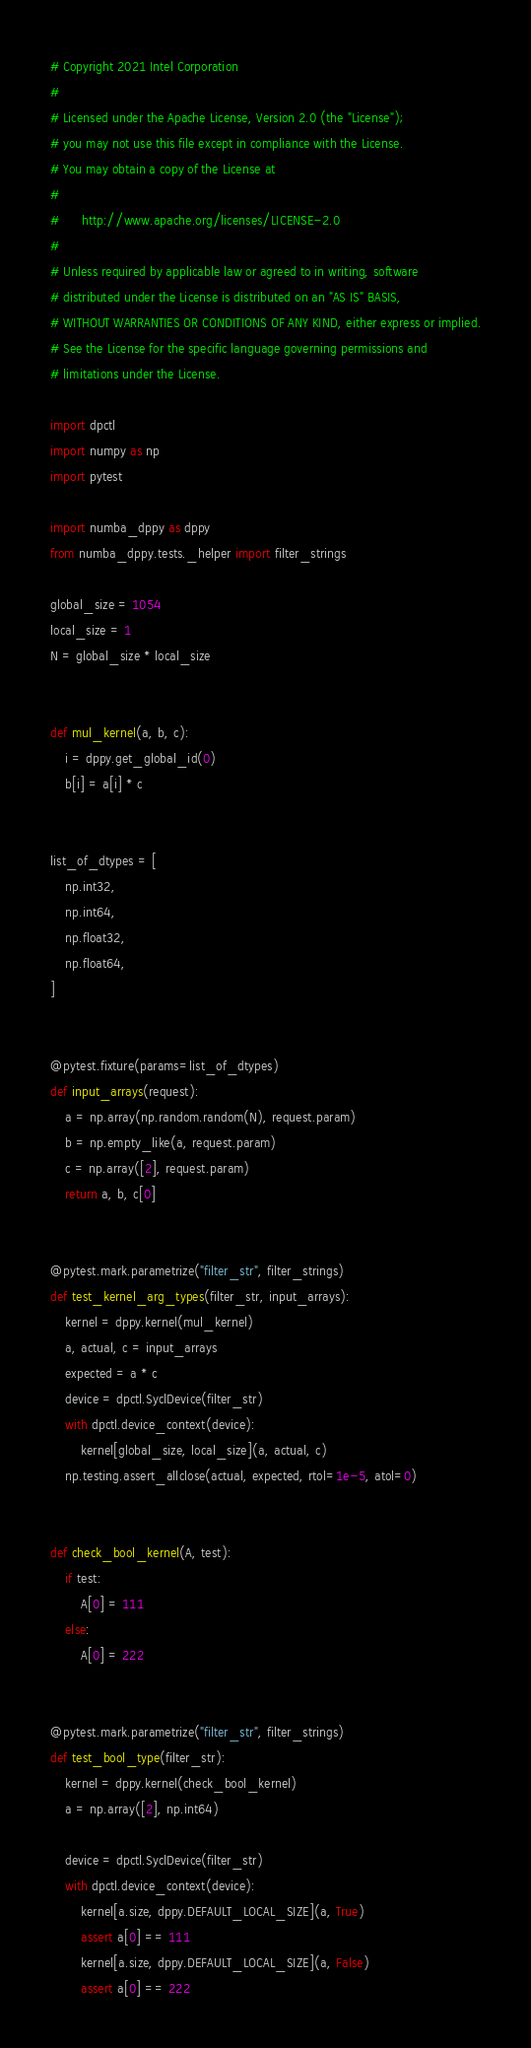Convert code to text. <code><loc_0><loc_0><loc_500><loc_500><_Python_># Copyright 2021 Intel Corporation
#
# Licensed under the Apache License, Version 2.0 (the "License");
# you may not use this file except in compliance with the License.
# You may obtain a copy of the License at
#
#      http://www.apache.org/licenses/LICENSE-2.0
#
# Unless required by applicable law or agreed to in writing, software
# distributed under the License is distributed on an "AS IS" BASIS,
# WITHOUT WARRANTIES OR CONDITIONS OF ANY KIND, either express or implied.
# See the License for the specific language governing permissions and
# limitations under the License.

import dpctl
import numpy as np
import pytest

import numba_dppy as dppy
from numba_dppy.tests._helper import filter_strings

global_size = 1054
local_size = 1
N = global_size * local_size


def mul_kernel(a, b, c):
    i = dppy.get_global_id(0)
    b[i] = a[i] * c


list_of_dtypes = [
    np.int32,
    np.int64,
    np.float32,
    np.float64,
]


@pytest.fixture(params=list_of_dtypes)
def input_arrays(request):
    a = np.array(np.random.random(N), request.param)
    b = np.empty_like(a, request.param)
    c = np.array([2], request.param)
    return a, b, c[0]


@pytest.mark.parametrize("filter_str", filter_strings)
def test_kernel_arg_types(filter_str, input_arrays):
    kernel = dppy.kernel(mul_kernel)
    a, actual, c = input_arrays
    expected = a * c
    device = dpctl.SyclDevice(filter_str)
    with dpctl.device_context(device):
        kernel[global_size, local_size](a, actual, c)
    np.testing.assert_allclose(actual, expected, rtol=1e-5, atol=0)


def check_bool_kernel(A, test):
    if test:
        A[0] = 111
    else:
        A[0] = 222


@pytest.mark.parametrize("filter_str", filter_strings)
def test_bool_type(filter_str):
    kernel = dppy.kernel(check_bool_kernel)
    a = np.array([2], np.int64)

    device = dpctl.SyclDevice(filter_str)
    with dpctl.device_context(device):
        kernel[a.size, dppy.DEFAULT_LOCAL_SIZE](a, True)
        assert a[0] == 111
        kernel[a.size, dppy.DEFAULT_LOCAL_SIZE](a, False)
        assert a[0] == 222
</code> 